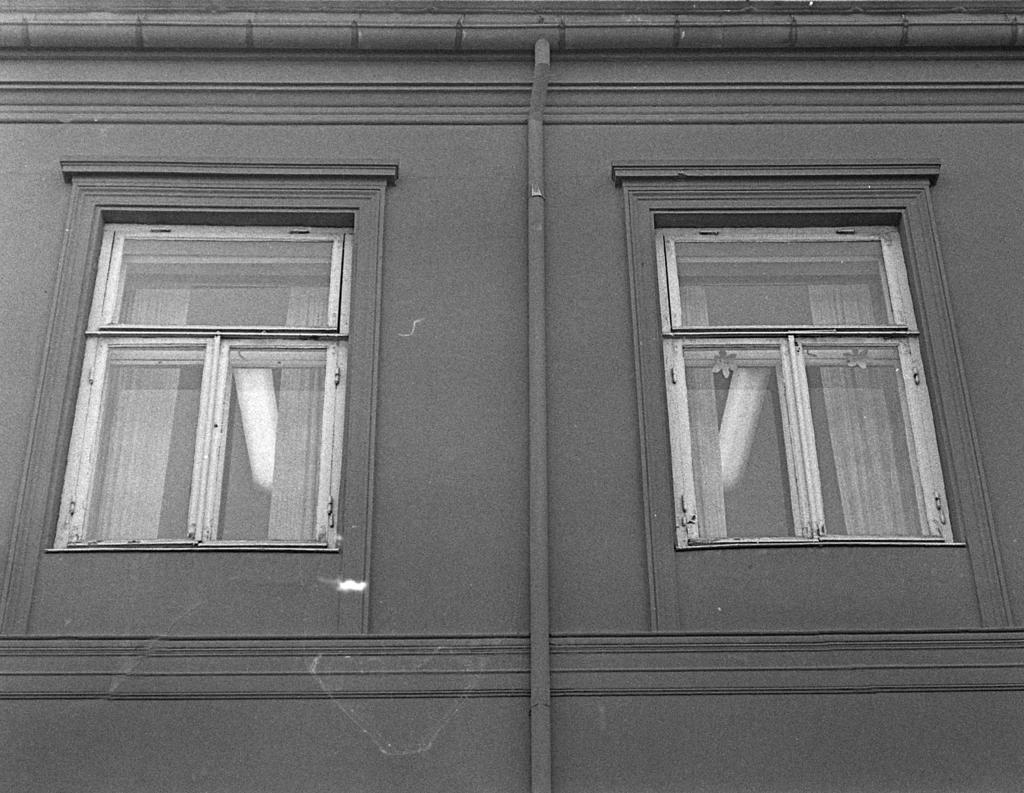Please provide a concise description of this image. It is a black and white image, there is a building and there are two windows to that building. 